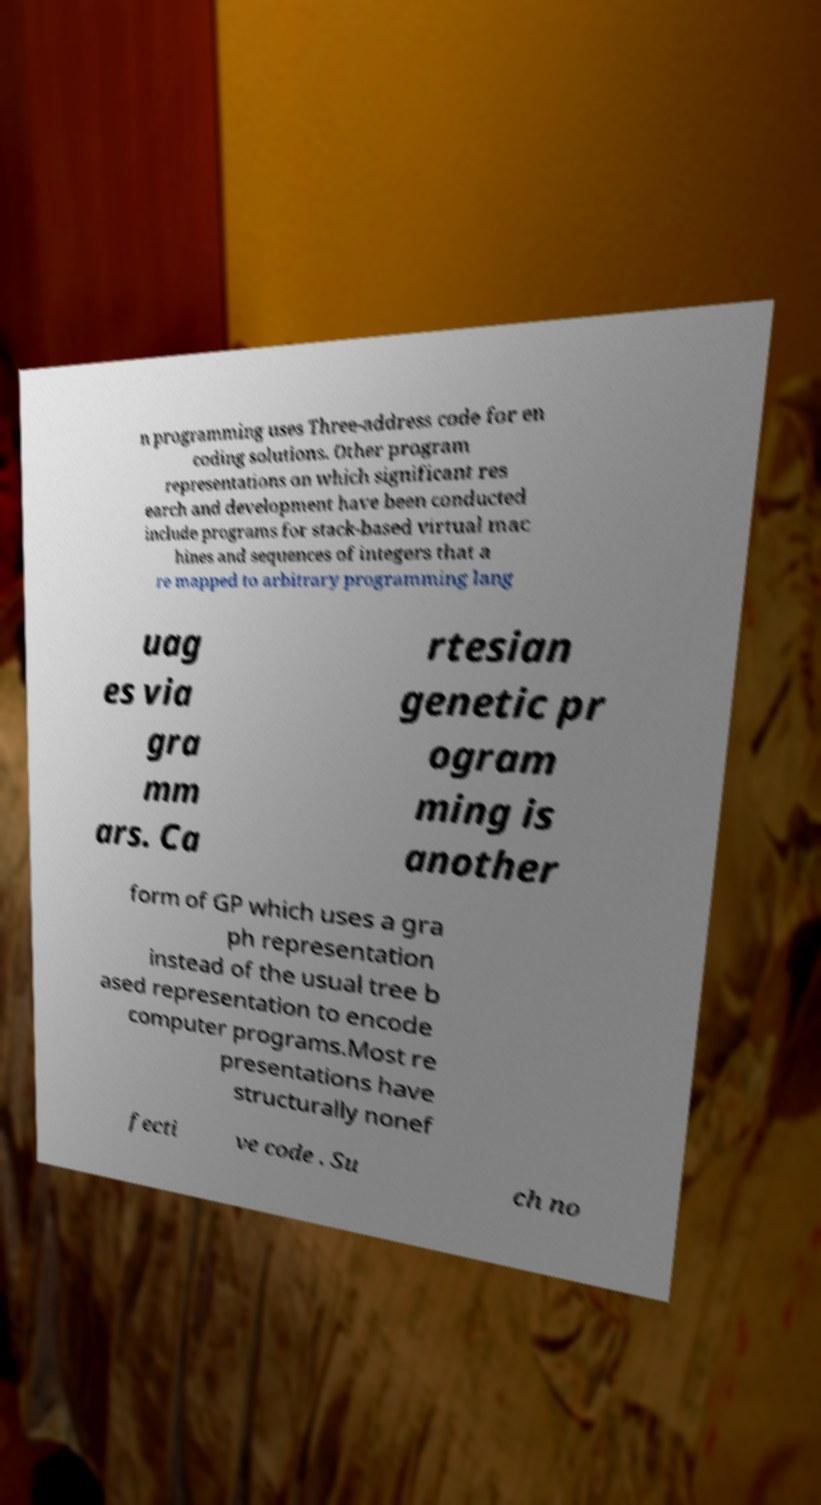Please identify and transcribe the text found in this image. n programming uses Three-address code for en coding solutions. Other program representations on which significant res earch and development have been conducted include programs for stack-based virtual mac hines and sequences of integers that a re mapped to arbitrary programming lang uag es via gra mm ars. Ca rtesian genetic pr ogram ming is another form of GP which uses a gra ph representation instead of the usual tree b ased representation to encode computer programs.Most re presentations have structurally nonef fecti ve code . Su ch no 